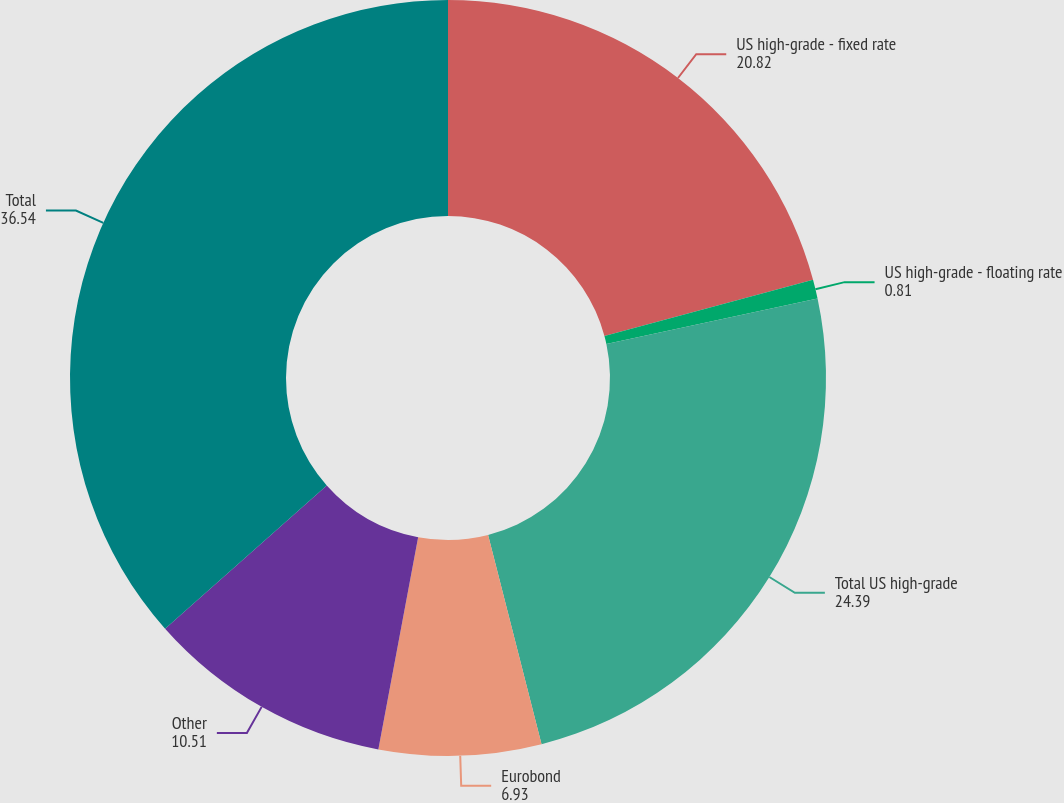<chart> <loc_0><loc_0><loc_500><loc_500><pie_chart><fcel>US high-grade - fixed rate<fcel>US high-grade - floating rate<fcel>Total US high-grade<fcel>Eurobond<fcel>Other<fcel>Total<nl><fcel>20.82%<fcel>0.81%<fcel>24.39%<fcel>6.93%<fcel>10.51%<fcel>36.54%<nl></chart> 